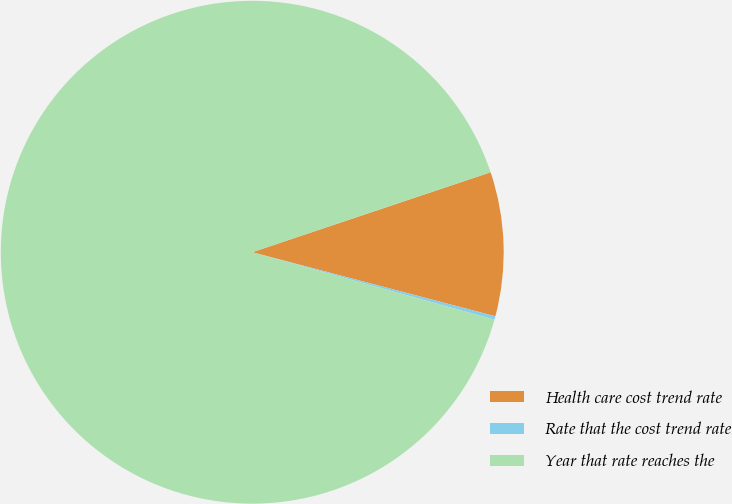<chart> <loc_0><loc_0><loc_500><loc_500><pie_chart><fcel>Health care cost trend rate<fcel>Rate that the cost trend rate<fcel>Year that rate reaches the<nl><fcel>9.25%<fcel>0.22%<fcel>90.52%<nl></chart> 